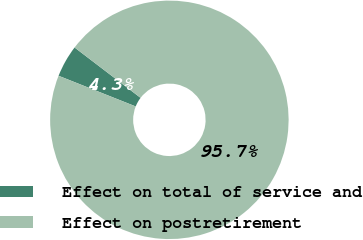<chart> <loc_0><loc_0><loc_500><loc_500><pie_chart><fcel>Effect on total of service and<fcel>Effect on postretirement<nl><fcel>4.35%<fcel>95.65%<nl></chart> 